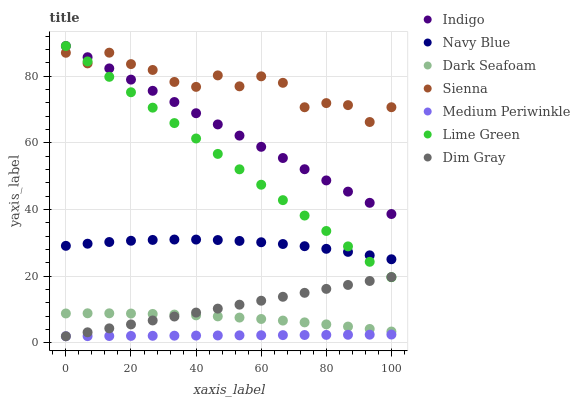Does Medium Periwinkle have the minimum area under the curve?
Answer yes or no. Yes. Does Sienna have the maximum area under the curve?
Answer yes or no. Yes. Does Indigo have the minimum area under the curve?
Answer yes or no. No. Does Indigo have the maximum area under the curve?
Answer yes or no. No. Is Medium Periwinkle the smoothest?
Answer yes or no. Yes. Is Sienna the roughest?
Answer yes or no. Yes. Is Indigo the smoothest?
Answer yes or no. No. Is Indigo the roughest?
Answer yes or no. No. Does Dim Gray have the lowest value?
Answer yes or no. Yes. Does Indigo have the lowest value?
Answer yes or no. No. Does Lime Green have the highest value?
Answer yes or no. Yes. Does Navy Blue have the highest value?
Answer yes or no. No. Is Dark Seafoam less than Sienna?
Answer yes or no. Yes. Is Sienna greater than Dark Seafoam?
Answer yes or no. Yes. Does Lime Green intersect Navy Blue?
Answer yes or no. Yes. Is Lime Green less than Navy Blue?
Answer yes or no. No. Is Lime Green greater than Navy Blue?
Answer yes or no. No. Does Dark Seafoam intersect Sienna?
Answer yes or no. No. 